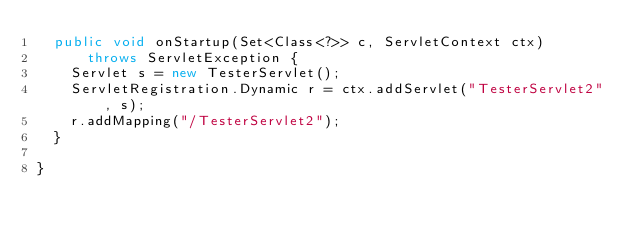Convert code to text. <code><loc_0><loc_0><loc_500><loc_500><_Java_>	public void onStartup(Set<Class<?>> c, ServletContext ctx)
			throws ServletException {
		Servlet s = new TesterServlet();
		ServletRegistration.Dynamic r = ctx.addServlet("TesterServlet2", s);
		r.addMapping("/TesterServlet2");
	}

}
</code> 